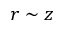<formula> <loc_0><loc_0><loc_500><loc_500>r \sim z</formula> 